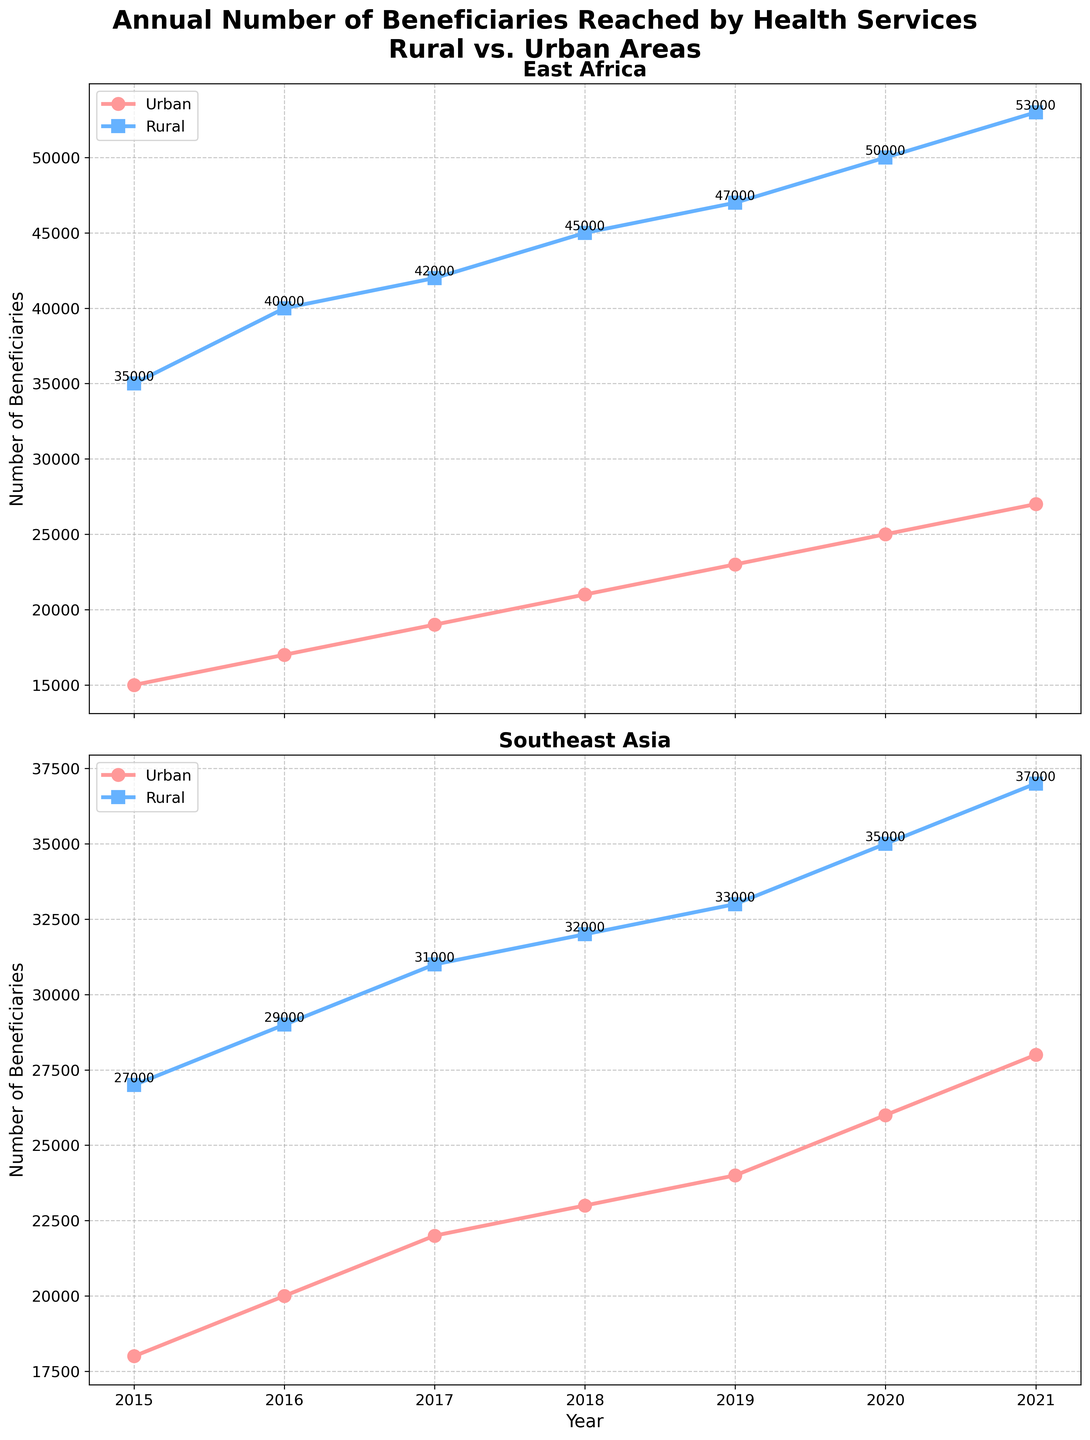What year did the number of urban beneficiaries in East Africa reach 25,000? The plot for East Africa shows that the number of urban beneficiaries reached 25,000 in 2020. By inspecting the data points and the number annotations, we can confirm this.
Answer: 2020 In Southeast Asia, was the number of rural beneficiaries higher or lower than urban beneficiaries in 2018? In the plot for Southeast Asia in 2018, the number of rural beneficiaries is 32,000 whereas the number of urban beneficiaries is 23,000. Comparing these values directly indicates that the number of rural beneficiaries is higher.
Answer: Higher Which region saw a consistent increase in the number of rural beneficiaries from 2015 to 2021? By looking at the plots, we can see that both East Africa and Southeast Asia show increasing trends in the number of rural beneficiaries from 2015 to 2021.
Answer: Both What was the difference in the number of urban beneficiaries between Southeast Asia and East Africa in 2016? In 2016, Southeast Asia had 20,000 urban beneficiaries and East Africa had 17,000 urban beneficiaries. By subtracting 17,000 from 20,000, we find the difference is 3,000.
Answer: 3,000 Did the number of rural beneficiaries in East Africa ever exceed 50,000? If so, in which year(s)? By checking the plotted lines for East Africa’s rural areas, we see that the number exceeds 50,000 in 2021 with a value of 53,000.
Answer: 2021 What is the average number of urban beneficiaries in Southeast Asia over the period from 2015 to 2021? The number of urban beneficiaries in Southeast Asia are 18,000 (2015), 20,000 (2016), 22,000 (2017), 23,000 (2018), 24,000 (2019), 26,000 (2020), and 28,000 (2021). Summing these values, we get 161,000, and dividing by 7 (the number of years), we find the average is 23,000.
Answer: 23,000 In which year did East Africa have the greatest difference between rural and urban beneficiaries? How much was the difference? We need to calculate the difference between rural and urban beneficiaries for each year in East Africa. The differences are: 2015 (20,000); 2016 (23,000); 2017 (23,000); 2018 (24,000); 2019 (24,000); 2020 (25,000); 2021 (26,000). The greatest difference is 26,000 in 2021.
Answer: 2021, 26,000 